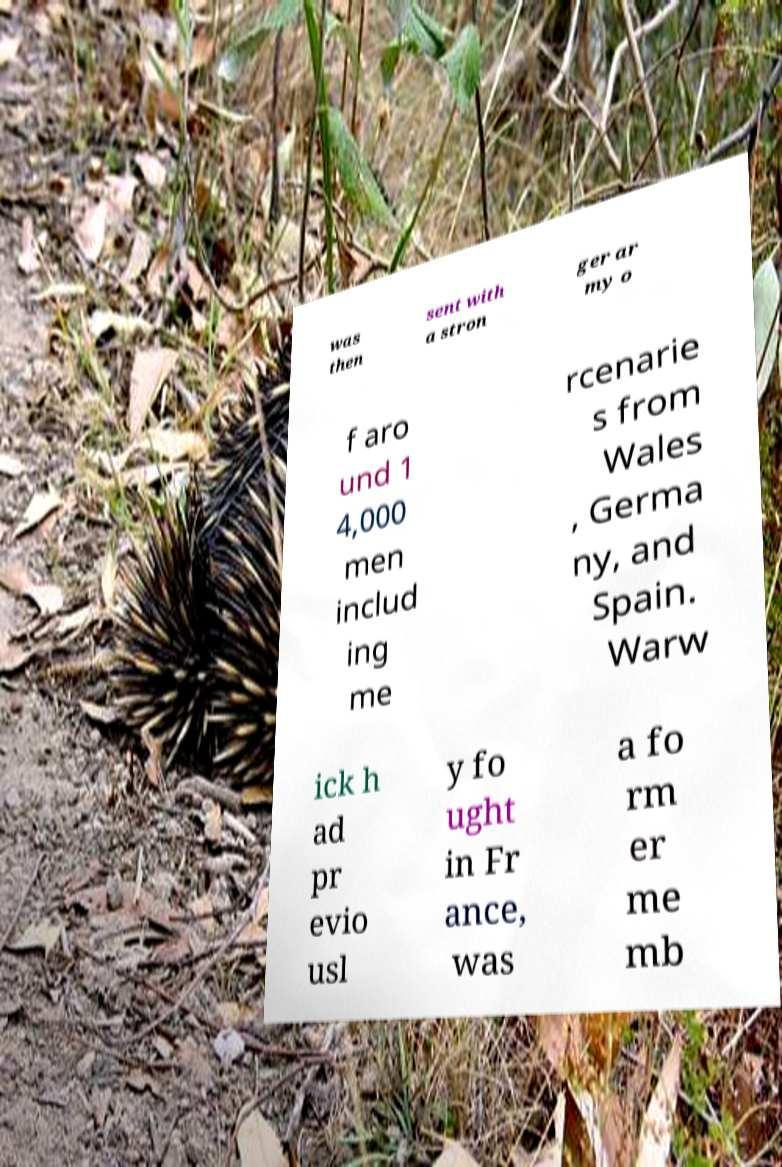Could you assist in decoding the text presented in this image and type it out clearly? was then sent with a stron ger ar my o f aro und 1 4,000 men includ ing me rcenarie s from Wales , Germa ny, and Spain. Warw ick h ad pr evio usl y fo ught in Fr ance, was a fo rm er me mb 